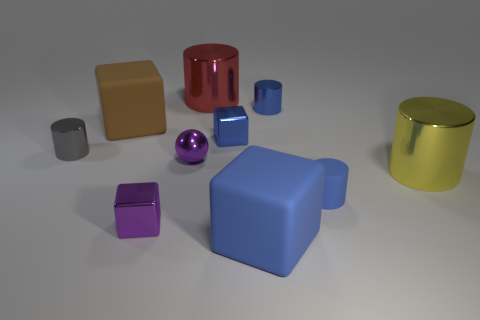Subtract all tiny rubber cylinders. How many cylinders are left? 4 Subtract all yellow cylinders. How many cylinders are left? 4 Subtract 1 cubes. How many cubes are left? 3 Subtract all cyan cylinders. Subtract all red cubes. How many cylinders are left? 5 Subtract all cubes. How many objects are left? 6 Subtract all large cyan objects. Subtract all blue metallic cubes. How many objects are left? 9 Add 5 gray shiny objects. How many gray shiny objects are left? 6 Add 5 big cylinders. How many big cylinders exist? 7 Subtract 1 yellow cylinders. How many objects are left? 9 